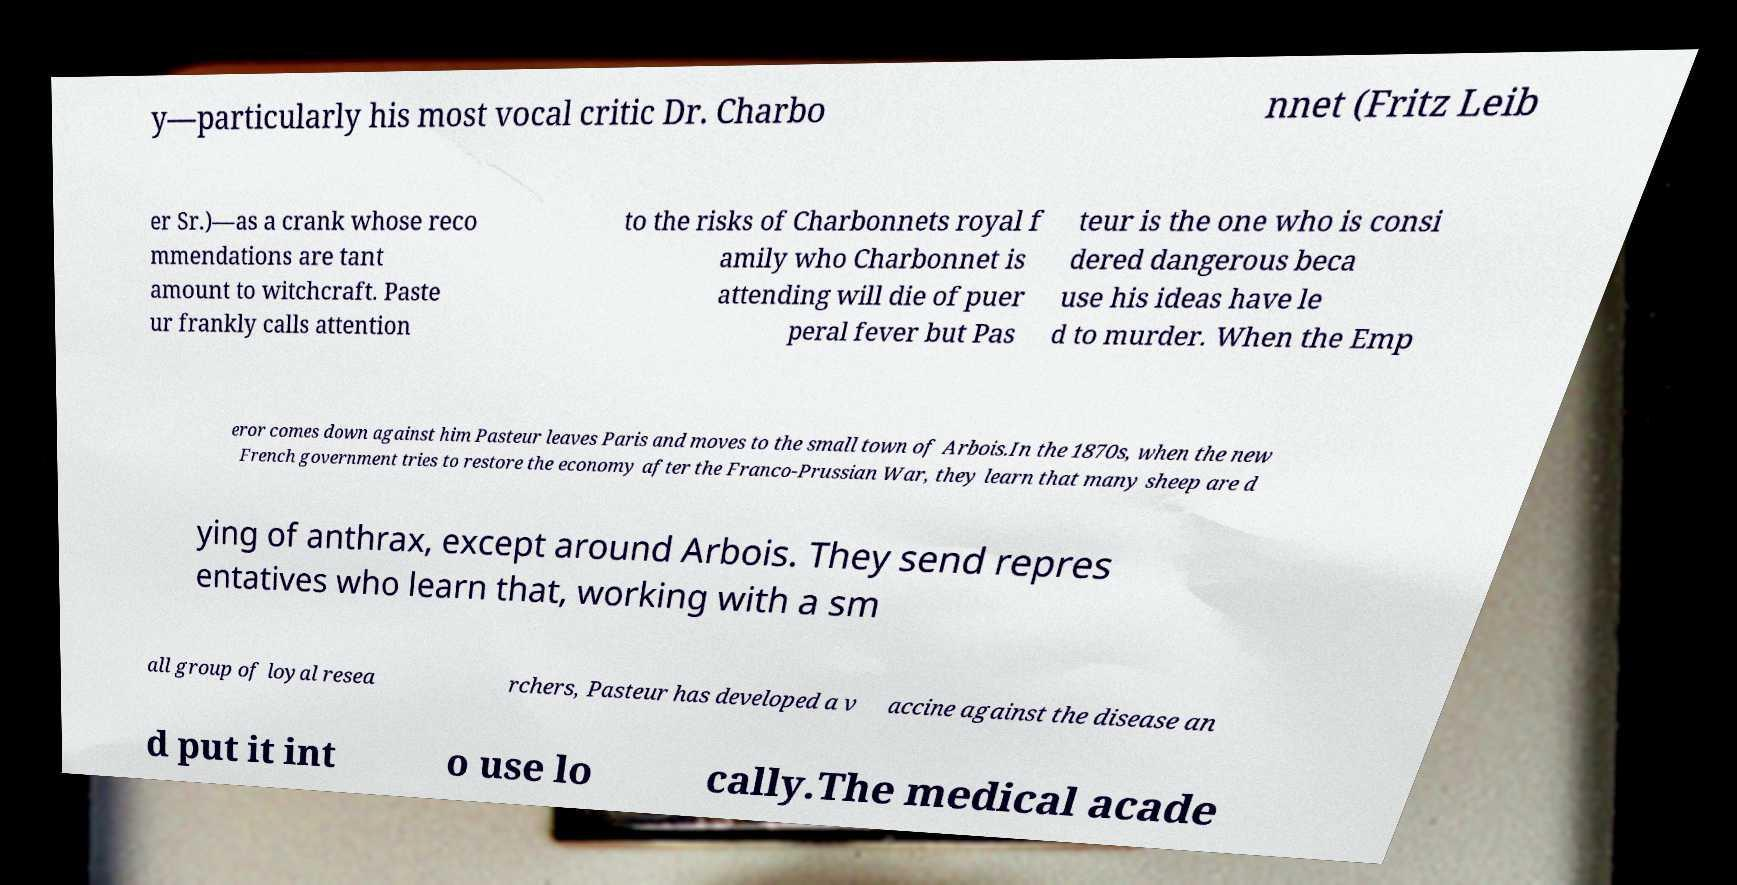Can you accurately transcribe the text from the provided image for me? y—particularly his most vocal critic Dr. Charbo nnet (Fritz Leib er Sr.)—as a crank whose reco mmendations are tant amount to witchcraft. Paste ur frankly calls attention to the risks of Charbonnets royal f amily who Charbonnet is attending will die of puer peral fever but Pas teur is the one who is consi dered dangerous beca use his ideas have le d to murder. When the Emp eror comes down against him Pasteur leaves Paris and moves to the small town of Arbois.In the 1870s, when the new French government tries to restore the economy after the Franco-Prussian War, they learn that many sheep are d ying of anthrax, except around Arbois. They send repres entatives who learn that, working with a sm all group of loyal resea rchers, Pasteur has developed a v accine against the disease an d put it int o use lo cally.The medical acade 